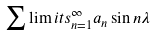<formula> <loc_0><loc_0><loc_500><loc_500>\sum \lim i t s _ { n = 1 } ^ { \infty } a _ { n } \sin n \lambda</formula> 